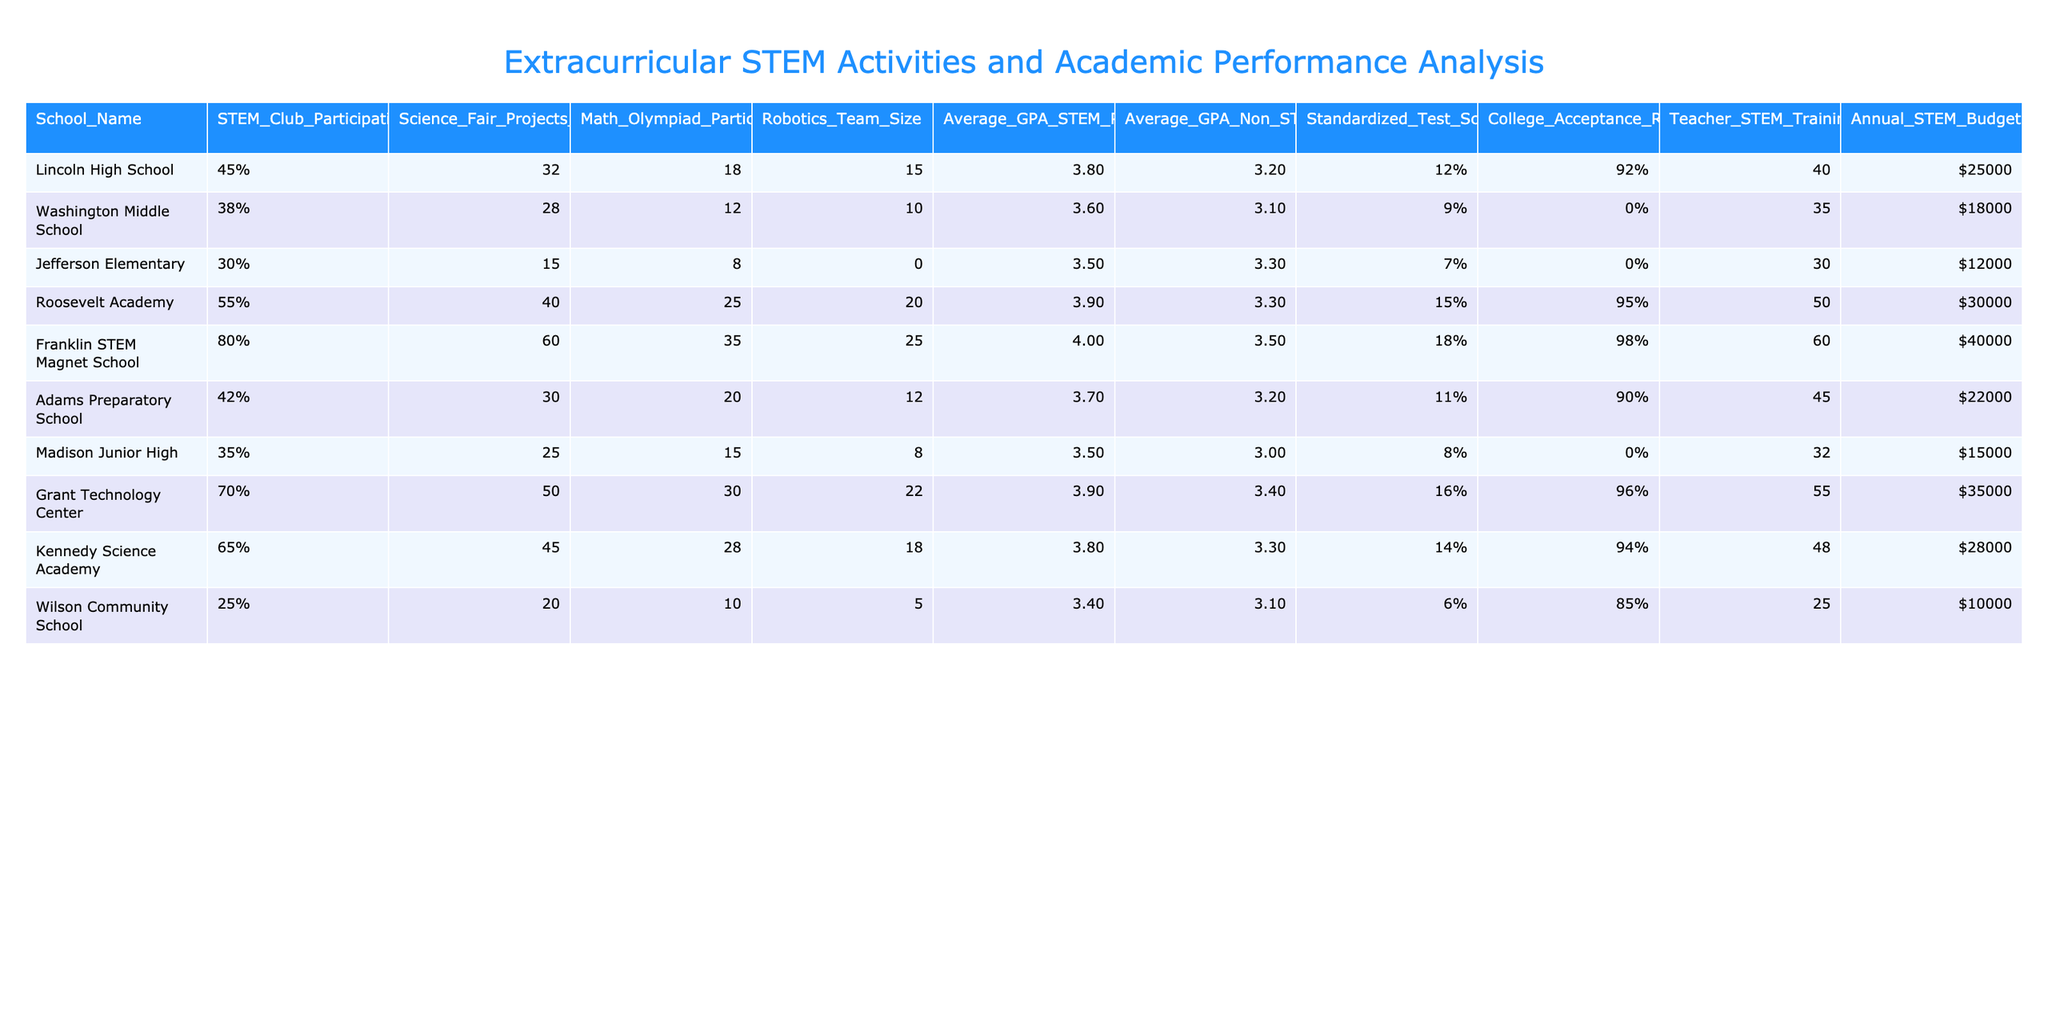What is the STEM Club Participation Rate for Franklin STEM Magnet School? According to the table, the STEM Club Participation Rate for Franklin STEM Magnet School is listed as 80%.
Answer: 80% Which school has the highest average GPA among STEM participants? The table shows that Franklin STEM Magnet School has the highest average GPA among STEM participants at 4.0.
Answer: 4.0 What is the difference in Standardized Test Score Improvement between Grant Technology Center and Wilson Community School? From the table, Grant Technology Center has a Standardized Test Score Improvement of 16%, while Wilson Community School has 6%. The difference is calculated as 16% - 6% = 10%.
Answer: 10% What is the average GPA of non-STEM participants across all schools? To find the average, we sum the average GPAs of non-STEM participants: (3.2 + 3.1 + 3.3 + 3.3 + 3.5 + 3.2 + 3.0 + 3.4 + 3.3 + 3.1) = 32.4. Dividing by the number of schools (10), we get 32.4 / 10 = 3.24.
Answer: 3.24 Does Roosevelt Academy have a higher College Acceptance Rate for STEM participants compared to Washington Middle School? Roosevelt Academy shows a College Acceptance Rate of 95%, while Washington Middle School has N/A, meaning it's not available. Therefore, the comparison cannot be made.
Answer: No What is the average size of the Robotics Teams across all the schools? The sizes of the Robotics Teams are: 15, 10, 0, 20, 25, 12, 8, 22, 18, and 5. The sum is 15 + 10 + 0 + 20 + 25 + 12 + 8 + 22 + 18 + 5 = 110. Dividing by the number of schools (10), we calculate the average size as 110 / 10 = 11.
Answer: 11 Which school has the lowest Annual STEM Budget, and what is the amount? Looking at the table, Wilson Community School has the lowest Annual STEM Budget listed at $10,000.
Answer: $10,000 If the Standardized Test Score Improvement for Franklin STEM Magnet School improves by another 5%, what would the new improvement be? Franklin STEM Magnet School currently has a Standardized Test Score Improvement of 18%. Adding the 5% improvement gives us 18% + 5% = 23%.
Answer: 23% Is the STEM Club Participation Rate for all schools above 30%? Checking the table, we see that Jefferson Elementary has a STEM Club Participation Rate of 30%, which meets the threshold, but Wilson Community School has a rate of 25%. Therefore, not all schools meet the criteria.
Answer: No Which school has the highest number of Math Olympiad Participants? The table shows that Franklin STEM Magnet School has the highest number of Math Olympiad Participants with 35.
Answer: 35 